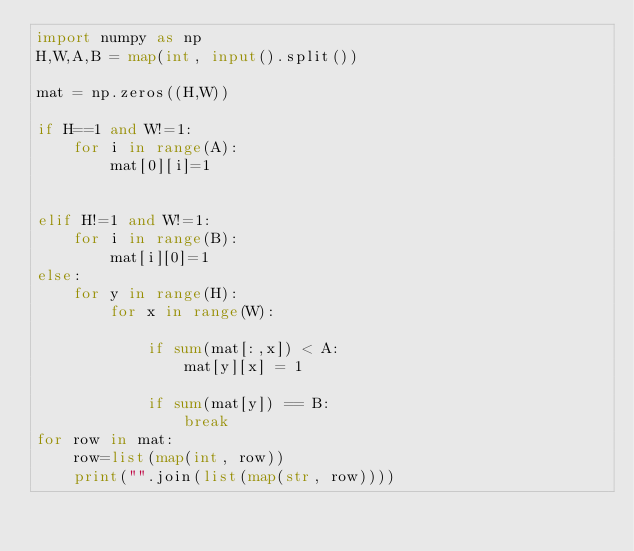Convert code to text. <code><loc_0><loc_0><loc_500><loc_500><_Python_>import numpy as np
H,W,A,B = map(int, input().split())

mat = np.zeros((H,W))

if H==1 and W!=1:
    for i in range(A):
        mat[0][i]=1
    
    
elif H!=1 and W!=1: 
    for i in range(B):
        mat[i][0]=1
else:
    for y in range(H):
        for x in range(W):

            if sum(mat[:,x]) < A:
                mat[y][x] = 1

            if sum(mat[y]) == B:
                break
for row in mat:
    row=list(map(int, row))
    print("".join(list(map(str, row))))</code> 